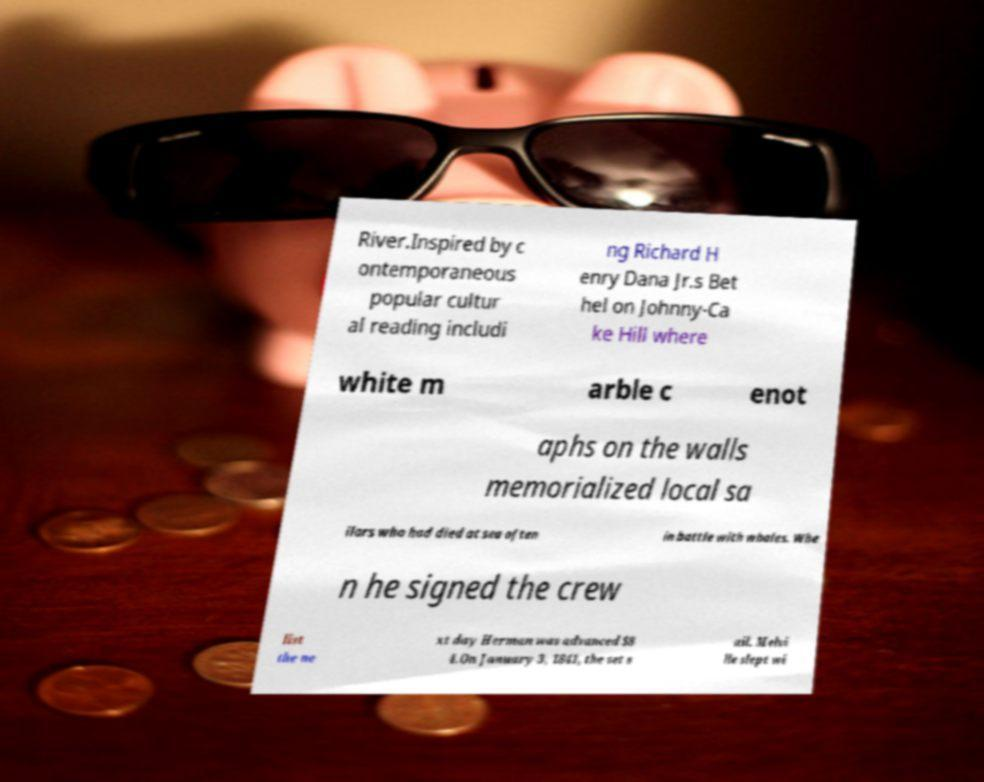Please identify and transcribe the text found in this image. River.Inspired by c ontemporaneous popular cultur al reading includi ng Richard H enry Dana Jr.s Bet hel on Johnny-Ca ke Hill where white m arble c enot aphs on the walls memorialized local sa ilors who had died at sea often in battle with whales. Whe n he signed the crew list the ne xt day Herman was advanced $8 4.On January 3, 1841, the set s ail. Melvi lle slept wi 